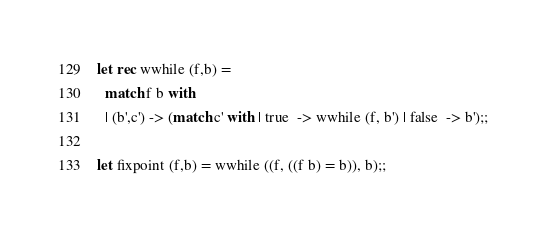<code> <loc_0><loc_0><loc_500><loc_500><_OCaml_>
let rec wwhile (f,b) =
  match f b with
  | (b',c') -> (match c' with | true  -> wwhile (f, b') | false  -> b');;

let fixpoint (f,b) = wwhile ((f, ((f b) = b)), b);;
</code> 